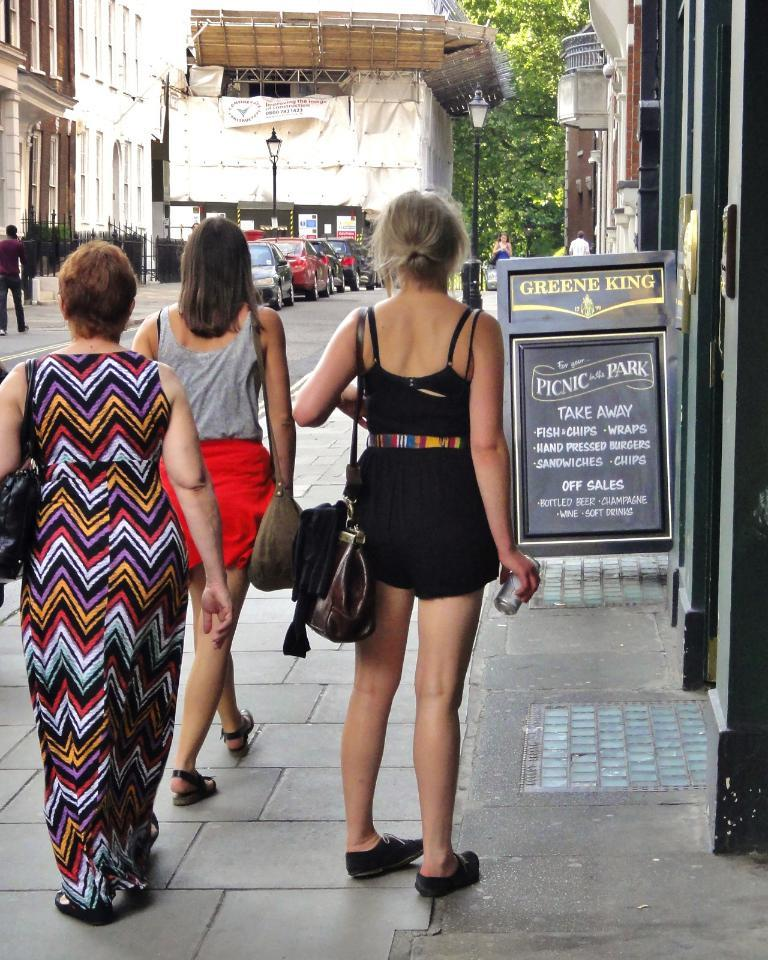How many people are standing on the footpath in the image? There are three people standing on the footpath in the image. What is located behind the people on the footpath? The footpath is in front of a building, which is in the background of the image. What can be seen in front of the building? There are cars in front of the buildings. What type of vegetation is present beside the building? Trees are present beside the building. What type of attraction is visible in the image? There is no specific attraction mentioned or visible in the image; it primarily features people, a footpath, a building, cars, and trees. Can you see a cub playing with the trees in the image? No, there is no cub or any animal present in the image; it only features people, a footpath, a building, cars, and trees. 